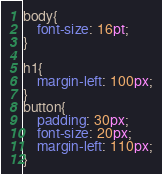Convert code to text. <code><loc_0><loc_0><loc_500><loc_500><_CSS_>body{
    font-size: 16pt;    
}

h1{
    margin-left: 100px;
}
button{
    padding: 30px;
    font-size: 20px;
    margin-left: 110px;
}</code> 